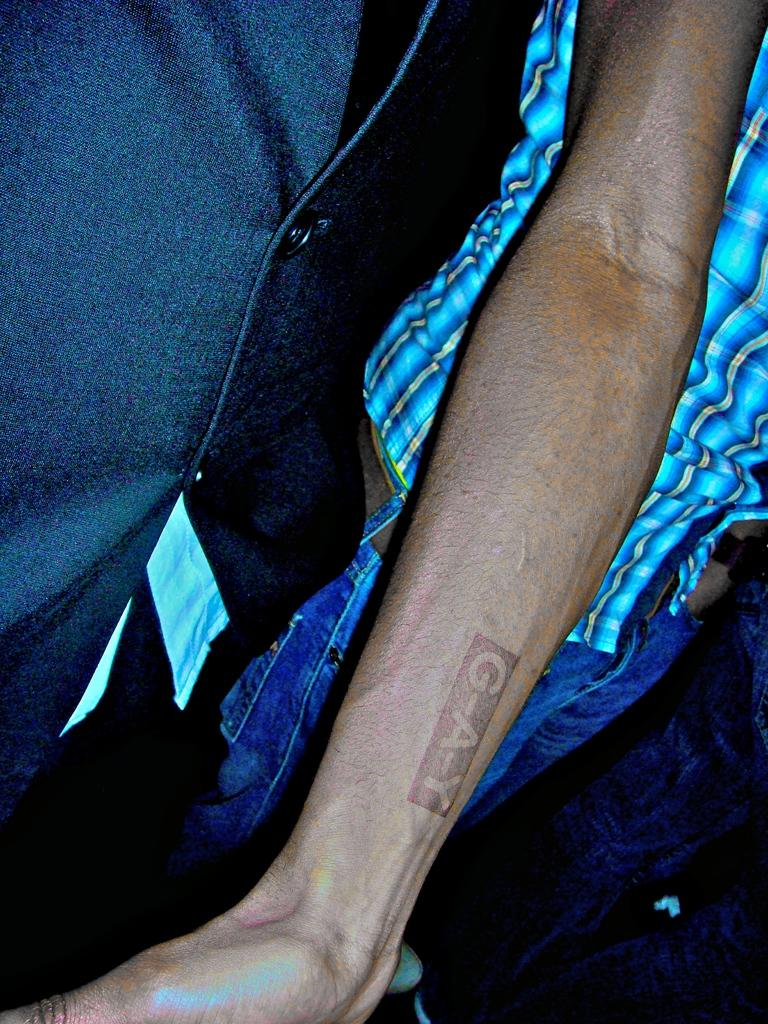What is on the person's hand in the image? There is a tattoo on a person's hand in the image. Can you describe the scene in the background? There is another person in the background. What type of clothing is the person in the background wearing? The person in the background is wearing jeans. What type of destruction can be seen in the room in the image? A: There is no room or destruction present in the image; it only features a tattoo on a person's hand and another person in the background. 